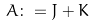<formula> <loc_0><loc_0><loc_500><loc_500>A \colon = J + K</formula> 